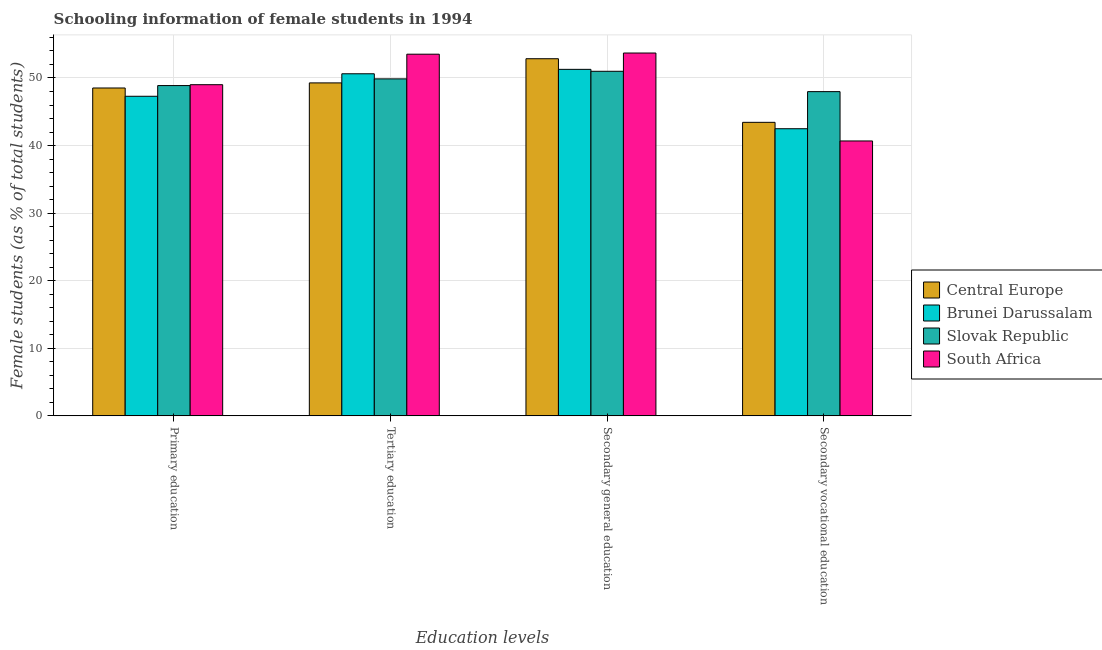Are the number of bars per tick equal to the number of legend labels?
Make the answer very short. Yes. How many bars are there on the 1st tick from the left?
Ensure brevity in your answer.  4. How many bars are there on the 3rd tick from the right?
Keep it short and to the point. 4. What is the label of the 4th group of bars from the left?
Ensure brevity in your answer.  Secondary vocational education. What is the percentage of female students in tertiary education in Brunei Darussalam?
Make the answer very short. 50.62. Across all countries, what is the maximum percentage of female students in secondary vocational education?
Offer a terse response. 47.98. Across all countries, what is the minimum percentage of female students in secondary education?
Your response must be concise. 50.99. In which country was the percentage of female students in secondary vocational education maximum?
Give a very brief answer. Slovak Republic. In which country was the percentage of female students in tertiary education minimum?
Offer a terse response. Central Europe. What is the total percentage of female students in tertiary education in the graph?
Offer a terse response. 203.28. What is the difference between the percentage of female students in tertiary education in South Africa and that in Central Europe?
Offer a terse response. 4.25. What is the difference between the percentage of female students in primary education in South Africa and the percentage of female students in secondary vocational education in Central Europe?
Your answer should be very brief. 5.57. What is the average percentage of female students in secondary vocational education per country?
Ensure brevity in your answer.  43.65. What is the difference between the percentage of female students in secondary education and percentage of female students in secondary vocational education in Brunei Darussalam?
Offer a very short reply. 8.79. What is the ratio of the percentage of female students in primary education in Slovak Republic to that in Central Europe?
Provide a short and direct response. 1.01. What is the difference between the highest and the second highest percentage of female students in tertiary education?
Ensure brevity in your answer.  2.9. What is the difference between the highest and the lowest percentage of female students in secondary education?
Make the answer very short. 2.7. In how many countries, is the percentage of female students in primary education greater than the average percentage of female students in primary education taken over all countries?
Provide a succinct answer. 3. Is the sum of the percentage of female students in secondary education in Brunei Darussalam and South Africa greater than the maximum percentage of female students in primary education across all countries?
Your answer should be very brief. Yes. What does the 3rd bar from the left in Tertiary education represents?
Provide a succinct answer. Slovak Republic. What does the 1st bar from the right in Tertiary education represents?
Ensure brevity in your answer.  South Africa. How many bars are there?
Provide a short and direct response. 16. How many countries are there in the graph?
Make the answer very short. 4. Are the values on the major ticks of Y-axis written in scientific E-notation?
Give a very brief answer. No. Does the graph contain any zero values?
Your answer should be very brief. No. Where does the legend appear in the graph?
Give a very brief answer. Center right. How many legend labels are there?
Provide a short and direct response. 4. How are the legend labels stacked?
Offer a very short reply. Vertical. What is the title of the graph?
Give a very brief answer. Schooling information of female students in 1994. Does "Zambia" appear as one of the legend labels in the graph?
Provide a short and direct response. No. What is the label or title of the X-axis?
Give a very brief answer. Education levels. What is the label or title of the Y-axis?
Your response must be concise. Female students (as % of total students). What is the Female students (as % of total students) in Central Europe in Primary education?
Offer a terse response. 48.52. What is the Female students (as % of total students) in Brunei Darussalam in Primary education?
Provide a succinct answer. 47.29. What is the Female students (as % of total students) of Slovak Republic in Primary education?
Provide a succinct answer. 48.88. What is the Female students (as % of total students) of South Africa in Primary education?
Keep it short and to the point. 49.01. What is the Female students (as % of total students) of Central Europe in Tertiary education?
Your answer should be compact. 49.27. What is the Female students (as % of total students) in Brunei Darussalam in Tertiary education?
Your answer should be compact. 50.62. What is the Female students (as % of total students) in Slovak Republic in Tertiary education?
Make the answer very short. 49.87. What is the Female students (as % of total students) in South Africa in Tertiary education?
Provide a short and direct response. 53.52. What is the Female students (as % of total students) of Central Europe in Secondary general education?
Your answer should be compact. 52.85. What is the Female students (as % of total students) in Brunei Darussalam in Secondary general education?
Give a very brief answer. 51.28. What is the Female students (as % of total students) in Slovak Republic in Secondary general education?
Your answer should be compact. 50.99. What is the Female students (as % of total students) in South Africa in Secondary general education?
Provide a short and direct response. 53.69. What is the Female students (as % of total students) of Central Europe in Secondary vocational education?
Keep it short and to the point. 43.44. What is the Female students (as % of total students) in Brunei Darussalam in Secondary vocational education?
Make the answer very short. 42.49. What is the Female students (as % of total students) in Slovak Republic in Secondary vocational education?
Your answer should be compact. 47.98. What is the Female students (as % of total students) in South Africa in Secondary vocational education?
Provide a short and direct response. 40.68. Across all Education levels, what is the maximum Female students (as % of total students) in Central Europe?
Ensure brevity in your answer.  52.85. Across all Education levels, what is the maximum Female students (as % of total students) in Brunei Darussalam?
Offer a terse response. 51.28. Across all Education levels, what is the maximum Female students (as % of total students) of Slovak Republic?
Offer a very short reply. 50.99. Across all Education levels, what is the maximum Female students (as % of total students) of South Africa?
Provide a succinct answer. 53.69. Across all Education levels, what is the minimum Female students (as % of total students) of Central Europe?
Provide a succinct answer. 43.44. Across all Education levels, what is the minimum Female students (as % of total students) of Brunei Darussalam?
Give a very brief answer. 42.49. Across all Education levels, what is the minimum Female students (as % of total students) of Slovak Republic?
Your answer should be very brief. 47.98. Across all Education levels, what is the minimum Female students (as % of total students) of South Africa?
Keep it short and to the point. 40.68. What is the total Female students (as % of total students) in Central Europe in the graph?
Your response must be concise. 194.08. What is the total Female students (as % of total students) of Brunei Darussalam in the graph?
Ensure brevity in your answer.  191.68. What is the total Female students (as % of total students) in Slovak Republic in the graph?
Provide a short and direct response. 197.72. What is the total Female students (as % of total students) of South Africa in the graph?
Your answer should be compact. 196.9. What is the difference between the Female students (as % of total students) in Central Europe in Primary education and that in Tertiary education?
Offer a terse response. -0.75. What is the difference between the Female students (as % of total students) in Brunei Darussalam in Primary education and that in Tertiary education?
Make the answer very short. -3.33. What is the difference between the Female students (as % of total students) of Slovak Republic in Primary education and that in Tertiary education?
Your answer should be compact. -0.99. What is the difference between the Female students (as % of total students) in South Africa in Primary education and that in Tertiary education?
Provide a succinct answer. -4.51. What is the difference between the Female students (as % of total students) of Central Europe in Primary education and that in Secondary general education?
Make the answer very short. -4.33. What is the difference between the Female students (as % of total students) of Brunei Darussalam in Primary education and that in Secondary general education?
Make the answer very short. -3.98. What is the difference between the Female students (as % of total students) of Slovak Republic in Primary education and that in Secondary general education?
Offer a terse response. -2.11. What is the difference between the Female students (as % of total students) of South Africa in Primary education and that in Secondary general education?
Your answer should be compact. -4.69. What is the difference between the Female students (as % of total students) of Central Europe in Primary education and that in Secondary vocational education?
Provide a short and direct response. 5.08. What is the difference between the Female students (as % of total students) of Brunei Darussalam in Primary education and that in Secondary vocational education?
Provide a short and direct response. 4.8. What is the difference between the Female students (as % of total students) of Slovak Republic in Primary education and that in Secondary vocational education?
Your response must be concise. 0.9. What is the difference between the Female students (as % of total students) of South Africa in Primary education and that in Secondary vocational education?
Ensure brevity in your answer.  8.32. What is the difference between the Female students (as % of total students) in Central Europe in Tertiary education and that in Secondary general education?
Keep it short and to the point. -3.58. What is the difference between the Female students (as % of total students) of Brunei Darussalam in Tertiary education and that in Secondary general education?
Offer a very short reply. -0.66. What is the difference between the Female students (as % of total students) of Slovak Republic in Tertiary education and that in Secondary general education?
Your answer should be compact. -1.12. What is the difference between the Female students (as % of total students) of South Africa in Tertiary education and that in Secondary general education?
Your answer should be very brief. -0.17. What is the difference between the Female students (as % of total students) in Central Europe in Tertiary education and that in Secondary vocational education?
Your answer should be very brief. 5.84. What is the difference between the Female students (as % of total students) in Brunei Darussalam in Tertiary education and that in Secondary vocational education?
Provide a short and direct response. 8.13. What is the difference between the Female students (as % of total students) in Slovak Republic in Tertiary education and that in Secondary vocational education?
Provide a succinct answer. 1.89. What is the difference between the Female students (as % of total students) of South Africa in Tertiary education and that in Secondary vocational education?
Provide a short and direct response. 12.84. What is the difference between the Female students (as % of total students) of Central Europe in Secondary general education and that in Secondary vocational education?
Your response must be concise. 9.41. What is the difference between the Female students (as % of total students) in Brunei Darussalam in Secondary general education and that in Secondary vocational education?
Make the answer very short. 8.79. What is the difference between the Female students (as % of total students) in Slovak Republic in Secondary general education and that in Secondary vocational education?
Your answer should be compact. 3.01. What is the difference between the Female students (as % of total students) in South Africa in Secondary general education and that in Secondary vocational education?
Make the answer very short. 13.01. What is the difference between the Female students (as % of total students) in Central Europe in Primary education and the Female students (as % of total students) in Brunei Darussalam in Tertiary education?
Your answer should be compact. -2.1. What is the difference between the Female students (as % of total students) of Central Europe in Primary education and the Female students (as % of total students) of Slovak Republic in Tertiary education?
Your answer should be very brief. -1.35. What is the difference between the Female students (as % of total students) in Central Europe in Primary education and the Female students (as % of total students) in South Africa in Tertiary education?
Give a very brief answer. -5. What is the difference between the Female students (as % of total students) of Brunei Darussalam in Primary education and the Female students (as % of total students) of Slovak Republic in Tertiary education?
Provide a short and direct response. -2.57. What is the difference between the Female students (as % of total students) in Brunei Darussalam in Primary education and the Female students (as % of total students) in South Africa in Tertiary education?
Ensure brevity in your answer.  -6.23. What is the difference between the Female students (as % of total students) of Slovak Republic in Primary education and the Female students (as % of total students) of South Africa in Tertiary education?
Ensure brevity in your answer.  -4.64. What is the difference between the Female students (as % of total students) in Central Europe in Primary education and the Female students (as % of total students) in Brunei Darussalam in Secondary general education?
Ensure brevity in your answer.  -2.76. What is the difference between the Female students (as % of total students) of Central Europe in Primary education and the Female students (as % of total students) of Slovak Republic in Secondary general education?
Offer a terse response. -2.47. What is the difference between the Female students (as % of total students) of Central Europe in Primary education and the Female students (as % of total students) of South Africa in Secondary general education?
Provide a succinct answer. -5.17. What is the difference between the Female students (as % of total students) of Brunei Darussalam in Primary education and the Female students (as % of total students) of Slovak Republic in Secondary general education?
Your response must be concise. -3.7. What is the difference between the Female students (as % of total students) in Brunei Darussalam in Primary education and the Female students (as % of total students) in South Africa in Secondary general education?
Provide a succinct answer. -6.4. What is the difference between the Female students (as % of total students) of Slovak Republic in Primary education and the Female students (as % of total students) of South Africa in Secondary general education?
Provide a succinct answer. -4.82. What is the difference between the Female students (as % of total students) in Central Europe in Primary education and the Female students (as % of total students) in Brunei Darussalam in Secondary vocational education?
Your answer should be very brief. 6.03. What is the difference between the Female students (as % of total students) of Central Europe in Primary education and the Female students (as % of total students) of Slovak Republic in Secondary vocational education?
Offer a terse response. 0.54. What is the difference between the Female students (as % of total students) of Central Europe in Primary education and the Female students (as % of total students) of South Africa in Secondary vocational education?
Make the answer very short. 7.84. What is the difference between the Female students (as % of total students) in Brunei Darussalam in Primary education and the Female students (as % of total students) in Slovak Republic in Secondary vocational education?
Keep it short and to the point. -0.69. What is the difference between the Female students (as % of total students) in Brunei Darussalam in Primary education and the Female students (as % of total students) in South Africa in Secondary vocational education?
Your answer should be very brief. 6.61. What is the difference between the Female students (as % of total students) in Slovak Republic in Primary education and the Female students (as % of total students) in South Africa in Secondary vocational education?
Your answer should be very brief. 8.2. What is the difference between the Female students (as % of total students) in Central Europe in Tertiary education and the Female students (as % of total students) in Brunei Darussalam in Secondary general education?
Offer a very short reply. -2. What is the difference between the Female students (as % of total students) of Central Europe in Tertiary education and the Female students (as % of total students) of Slovak Republic in Secondary general education?
Keep it short and to the point. -1.72. What is the difference between the Female students (as % of total students) in Central Europe in Tertiary education and the Female students (as % of total students) in South Africa in Secondary general education?
Your answer should be very brief. -4.42. What is the difference between the Female students (as % of total students) of Brunei Darussalam in Tertiary education and the Female students (as % of total students) of Slovak Republic in Secondary general education?
Ensure brevity in your answer.  -0.37. What is the difference between the Female students (as % of total students) in Brunei Darussalam in Tertiary education and the Female students (as % of total students) in South Africa in Secondary general education?
Offer a very short reply. -3.07. What is the difference between the Female students (as % of total students) of Slovak Republic in Tertiary education and the Female students (as % of total students) of South Africa in Secondary general education?
Give a very brief answer. -3.83. What is the difference between the Female students (as % of total students) in Central Europe in Tertiary education and the Female students (as % of total students) in Brunei Darussalam in Secondary vocational education?
Provide a short and direct response. 6.78. What is the difference between the Female students (as % of total students) in Central Europe in Tertiary education and the Female students (as % of total students) in Slovak Republic in Secondary vocational education?
Offer a terse response. 1.29. What is the difference between the Female students (as % of total students) of Central Europe in Tertiary education and the Female students (as % of total students) of South Africa in Secondary vocational education?
Your response must be concise. 8.59. What is the difference between the Female students (as % of total students) in Brunei Darussalam in Tertiary education and the Female students (as % of total students) in Slovak Republic in Secondary vocational education?
Provide a short and direct response. 2.64. What is the difference between the Female students (as % of total students) of Brunei Darussalam in Tertiary education and the Female students (as % of total students) of South Africa in Secondary vocational education?
Keep it short and to the point. 9.94. What is the difference between the Female students (as % of total students) in Slovak Republic in Tertiary education and the Female students (as % of total students) in South Africa in Secondary vocational education?
Ensure brevity in your answer.  9.19. What is the difference between the Female students (as % of total students) of Central Europe in Secondary general education and the Female students (as % of total students) of Brunei Darussalam in Secondary vocational education?
Provide a succinct answer. 10.36. What is the difference between the Female students (as % of total students) in Central Europe in Secondary general education and the Female students (as % of total students) in Slovak Republic in Secondary vocational education?
Provide a short and direct response. 4.87. What is the difference between the Female students (as % of total students) in Central Europe in Secondary general education and the Female students (as % of total students) in South Africa in Secondary vocational education?
Your response must be concise. 12.17. What is the difference between the Female students (as % of total students) in Brunei Darussalam in Secondary general education and the Female students (as % of total students) in Slovak Republic in Secondary vocational education?
Your answer should be compact. 3.3. What is the difference between the Female students (as % of total students) of Brunei Darussalam in Secondary general education and the Female students (as % of total students) of South Africa in Secondary vocational education?
Provide a short and direct response. 10.6. What is the difference between the Female students (as % of total students) of Slovak Republic in Secondary general education and the Female students (as % of total students) of South Africa in Secondary vocational education?
Your answer should be compact. 10.31. What is the average Female students (as % of total students) of Central Europe per Education levels?
Give a very brief answer. 48.52. What is the average Female students (as % of total students) in Brunei Darussalam per Education levels?
Your response must be concise. 47.92. What is the average Female students (as % of total students) of Slovak Republic per Education levels?
Give a very brief answer. 49.43. What is the average Female students (as % of total students) of South Africa per Education levels?
Provide a short and direct response. 49.23. What is the difference between the Female students (as % of total students) in Central Europe and Female students (as % of total students) in Brunei Darussalam in Primary education?
Your response must be concise. 1.23. What is the difference between the Female students (as % of total students) in Central Europe and Female students (as % of total students) in Slovak Republic in Primary education?
Provide a short and direct response. -0.36. What is the difference between the Female students (as % of total students) in Central Europe and Female students (as % of total students) in South Africa in Primary education?
Give a very brief answer. -0.49. What is the difference between the Female students (as % of total students) in Brunei Darussalam and Female students (as % of total students) in Slovak Republic in Primary education?
Offer a very short reply. -1.58. What is the difference between the Female students (as % of total students) of Brunei Darussalam and Female students (as % of total students) of South Africa in Primary education?
Keep it short and to the point. -1.71. What is the difference between the Female students (as % of total students) in Slovak Republic and Female students (as % of total students) in South Africa in Primary education?
Provide a short and direct response. -0.13. What is the difference between the Female students (as % of total students) of Central Europe and Female students (as % of total students) of Brunei Darussalam in Tertiary education?
Ensure brevity in your answer.  -1.35. What is the difference between the Female students (as % of total students) in Central Europe and Female students (as % of total students) in Slovak Republic in Tertiary education?
Your answer should be compact. -0.59. What is the difference between the Female students (as % of total students) in Central Europe and Female students (as % of total students) in South Africa in Tertiary education?
Provide a short and direct response. -4.25. What is the difference between the Female students (as % of total students) of Brunei Darussalam and Female students (as % of total students) of Slovak Republic in Tertiary education?
Provide a short and direct response. 0.76. What is the difference between the Female students (as % of total students) of Brunei Darussalam and Female students (as % of total students) of South Africa in Tertiary education?
Make the answer very short. -2.9. What is the difference between the Female students (as % of total students) of Slovak Republic and Female students (as % of total students) of South Africa in Tertiary education?
Make the answer very short. -3.65. What is the difference between the Female students (as % of total students) of Central Europe and Female students (as % of total students) of Brunei Darussalam in Secondary general education?
Offer a terse response. 1.57. What is the difference between the Female students (as % of total students) of Central Europe and Female students (as % of total students) of Slovak Republic in Secondary general education?
Provide a succinct answer. 1.86. What is the difference between the Female students (as % of total students) in Central Europe and Female students (as % of total students) in South Africa in Secondary general education?
Offer a very short reply. -0.85. What is the difference between the Female students (as % of total students) in Brunei Darussalam and Female students (as % of total students) in Slovak Republic in Secondary general education?
Provide a short and direct response. 0.29. What is the difference between the Female students (as % of total students) in Brunei Darussalam and Female students (as % of total students) in South Africa in Secondary general education?
Offer a very short reply. -2.42. What is the difference between the Female students (as % of total students) in Slovak Republic and Female students (as % of total students) in South Africa in Secondary general education?
Keep it short and to the point. -2.7. What is the difference between the Female students (as % of total students) in Central Europe and Female students (as % of total students) in Brunei Darussalam in Secondary vocational education?
Your response must be concise. 0.94. What is the difference between the Female students (as % of total students) of Central Europe and Female students (as % of total students) of Slovak Republic in Secondary vocational education?
Ensure brevity in your answer.  -4.54. What is the difference between the Female students (as % of total students) of Central Europe and Female students (as % of total students) of South Africa in Secondary vocational education?
Provide a short and direct response. 2.76. What is the difference between the Female students (as % of total students) of Brunei Darussalam and Female students (as % of total students) of Slovak Republic in Secondary vocational education?
Your response must be concise. -5.49. What is the difference between the Female students (as % of total students) of Brunei Darussalam and Female students (as % of total students) of South Africa in Secondary vocational education?
Provide a succinct answer. 1.81. What is the difference between the Female students (as % of total students) in Slovak Republic and Female students (as % of total students) in South Africa in Secondary vocational education?
Make the answer very short. 7.3. What is the ratio of the Female students (as % of total students) in Central Europe in Primary education to that in Tertiary education?
Give a very brief answer. 0.98. What is the ratio of the Female students (as % of total students) of Brunei Darussalam in Primary education to that in Tertiary education?
Make the answer very short. 0.93. What is the ratio of the Female students (as % of total students) of Slovak Republic in Primary education to that in Tertiary education?
Provide a succinct answer. 0.98. What is the ratio of the Female students (as % of total students) in South Africa in Primary education to that in Tertiary education?
Provide a short and direct response. 0.92. What is the ratio of the Female students (as % of total students) in Central Europe in Primary education to that in Secondary general education?
Provide a succinct answer. 0.92. What is the ratio of the Female students (as % of total students) of Brunei Darussalam in Primary education to that in Secondary general education?
Your answer should be very brief. 0.92. What is the ratio of the Female students (as % of total students) in Slovak Republic in Primary education to that in Secondary general education?
Offer a terse response. 0.96. What is the ratio of the Female students (as % of total students) of South Africa in Primary education to that in Secondary general education?
Ensure brevity in your answer.  0.91. What is the ratio of the Female students (as % of total students) of Central Europe in Primary education to that in Secondary vocational education?
Your response must be concise. 1.12. What is the ratio of the Female students (as % of total students) of Brunei Darussalam in Primary education to that in Secondary vocational education?
Offer a very short reply. 1.11. What is the ratio of the Female students (as % of total students) in Slovak Republic in Primary education to that in Secondary vocational education?
Your answer should be compact. 1.02. What is the ratio of the Female students (as % of total students) in South Africa in Primary education to that in Secondary vocational education?
Your answer should be compact. 1.2. What is the ratio of the Female students (as % of total students) in Central Europe in Tertiary education to that in Secondary general education?
Offer a terse response. 0.93. What is the ratio of the Female students (as % of total students) of Brunei Darussalam in Tertiary education to that in Secondary general education?
Offer a terse response. 0.99. What is the ratio of the Female students (as % of total students) of South Africa in Tertiary education to that in Secondary general education?
Offer a very short reply. 1. What is the ratio of the Female students (as % of total students) of Central Europe in Tertiary education to that in Secondary vocational education?
Ensure brevity in your answer.  1.13. What is the ratio of the Female students (as % of total students) in Brunei Darussalam in Tertiary education to that in Secondary vocational education?
Your answer should be compact. 1.19. What is the ratio of the Female students (as % of total students) in Slovak Republic in Tertiary education to that in Secondary vocational education?
Your answer should be very brief. 1.04. What is the ratio of the Female students (as % of total students) of South Africa in Tertiary education to that in Secondary vocational education?
Make the answer very short. 1.32. What is the ratio of the Female students (as % of total students) in Central Europe in Secondary general education to that in Secondary vocational education?
Keep it short and to the point. 1.22. What is the ratio of the Female students (as % of total students) of Brunei Darussalam in Secondary general education to that in Secondary vocational education?
Keep it short and to the point. 1.21. What is the ratio of the Female students (as % of total students) in Slovak Republic in Secondary general education to that in Secondary vocational education?
Keep it short and to the point. 1.06. What is the ratio of the Female students (as % of total students) of South Africa in Secondary general education to that in Secondary vocational education?
Your response must be concise. 1.32. What is the difference between the highest and the second highest Female students (as % of total students) of Central Europe?
Your answer should be compact. 3.58. What is the difference between the highest and the second highest Female students (as % of total students) in Brunei Darussalam?
Offer a terse response. 0.66. What is the difference between the highest and the second highest Female students (as % of total students) of Slovak Republic?
Keep it short and to the point. 1.12. What is the difference between the highest and the second highest Female students (as % of total students) of South Africa?
Make the answer very short. 0.17. What is the difference between the highest and the lowest Female students (as % of total students) of Central Europe?
Make the answer very short. 9.41. What is the difference between the highest and the lowest Female students (as % of total students) of Brunei Darussalam?
Provide a short and direct response. 8.79. What is the difference between the highest and the lowest Female students (as % of total students) in Slovak Republic?
Your response must be concise. 3.01. What is the difference between the highest and the lowest Female students (as % of total students) in South Africa?
Offer a very short reply. 13.01. 